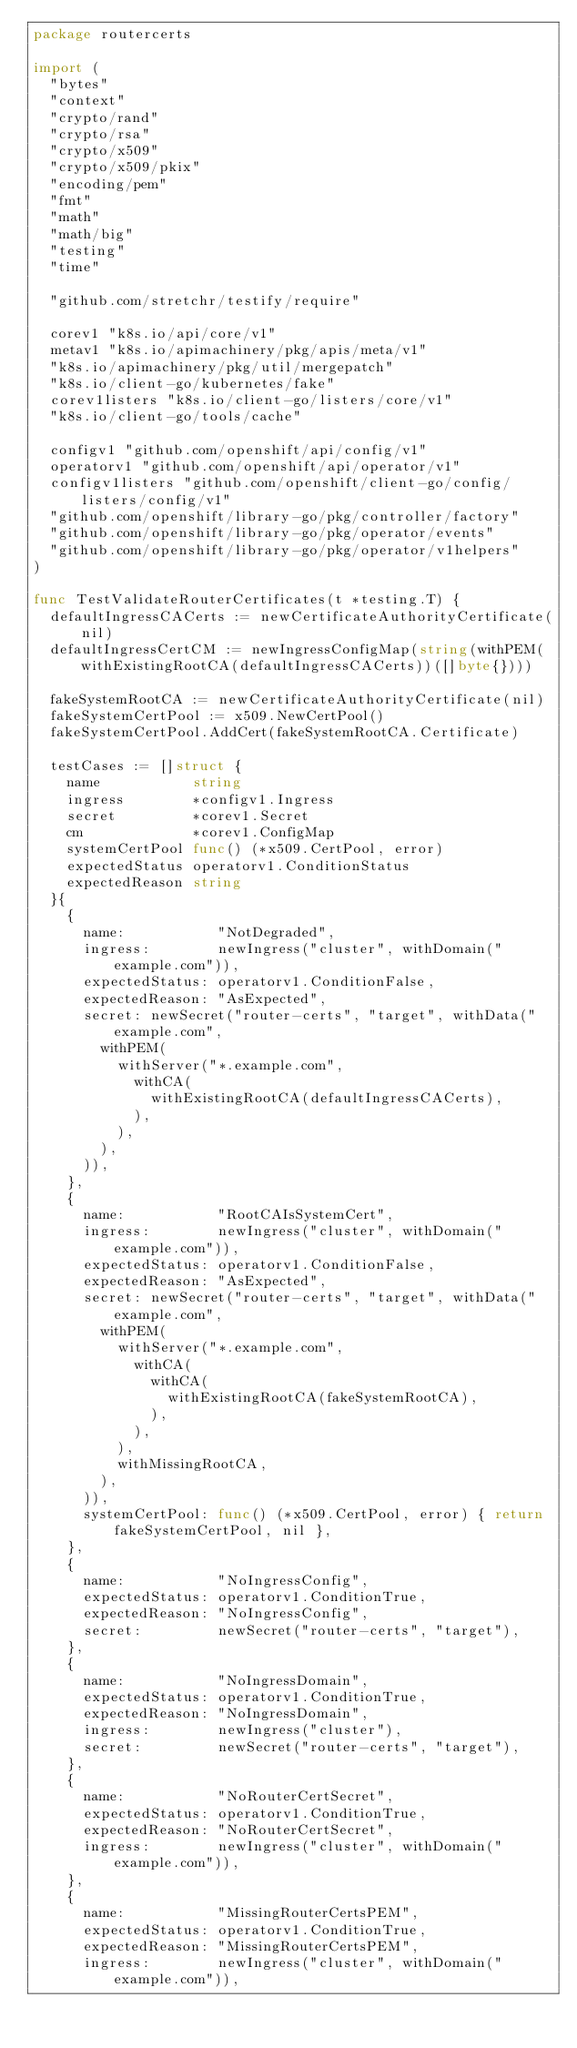<code> <loc_0><loc_0><loc_500><loc_500><_Go_>package routercerts

import (
	"bytes"
	"context"
	"crypto/rand"
	"crypto/rsa"
	"crypto/x509"
	"crypto/x509/pkix"
	"encoding/pem"
	"fmt"
	"math"
	"math/big"
	"testing"
	"time"

	"github.com/stretchr/testify/require"

	corev1 "k8s.io/api/core/v1"
	metav1 "k8s.io/apimachinery/pkg/apis/meta/v1"
	"k8s.io/apimachinery/pkg/util/mergepatch"
	"k8s.io/client-go/kubernetes/fake"
	corev1listers "k8s.io/client-go/listers/core/v1"
	"k8s.io/client-go/tools/cache"

	configv1 "github.com/openshift/api/config/v1"
	operatorv1 "github.com/openshift/api/operator/v1"
	configv1listers "github.com/openshift/client-go/config/listers/config/v1"
	"github.com/openshift/library-go/pkg/controller/factory"
	"github.com/openshift/library-go/pkg/operator/events"
	"github.com/openshift/library-go/pkg/operator/v1helpers"
)

func TestValidateRouterCertificates(t *testing.T) {
	defaultIngressCACerts := newCertificateAuthorityCertificate(nil)
	defaultIngressCertCM := newIngressConfigMap(string(withPEM(withExistingRootCA(defaultIngressCACerts))([]byte{})))

	fakeSystemRootCA := newCertificateAuthorityCertificate(nil)
	fakeSystemCertPool := x509.NewCertPool()
	fakeSystemCertPool.AddCert(fakeSystemRootCA.Certificate)

	testCases := []struct {
		name           string
		ingress        *configv1.Ingress
		secret         *corev1.Secret
		cm             *corev1.ConfigMap
		systemCertPool func() (*x509.CertPool, error)
		expectedStatus operatorv1.ConditionStatus
		expectedReason string
	}{
		{
			name:           "NotDegraded",
			ingress:        newIngress("cluster", withDomain("example.com")),
			expectedStatus: operatorv1.ConditionFalse,
			expectedReason: "AsExpected",
			secret: newSecret("router-certs", "target", withData("example.com",
				withPEM(
					withServer("*.example.com",
						withCA(
							withExistingRootCA(defaultIngressCACerts),
						),
					),
				),
			)),
		},
		{
			name:           "RootCAIsSystemCert",
			ingress:        newIngress("cluster", withDomain("example.com")),
			expectedStatus: operatorv1.ConditionFalse,
			expectedReason: "AsExpected",
			secret: newSecret("router-certs", "target", withData("example.com",
				withPEM(
					withServer("*.example.com",
						withCA(
							withCA(
								withExistingRootCA(fakeSystemRootCA),
							),
						),
					),
					withMissingRootCA,
				),
			)),
			systemCertPool: func() (*x509.CertPool, error) { return fakeSystemCertPool, nil },
		},
		{
			name:           "NoIngressConfig",
			expectedStatus: operatorv1.ConditionTrue,
			expectedReason: "NoIngressConfig",
			secret:         newSecret("router-certs", "target"),
		},
		{
			name:           "NoIngressDomain",
			expectedStatus: operatorv1.ConditionTrue,
			expectedReason: "NoIngressDomain",
			ingress:        newIngress("cluster"),
			secret:         newSecret("router-certs", "target"),
		},
		{
			name:           "NoRouterCertSecret",
			expectedStatus: operatorv1.ConditionTrue,
			expectedReason: "NoRouterCertSecret",
			ingress:        newIngress("cluster", withDomain("example.com")),
		},
		{
			name:           "MissingRouterCertsPEM",
			expectedStatus: operatorv1.ConditionTrue,
			expectedReason: "MissingRouterCertsPEM",
			ingress:        newIngress("cluster", withDomain("example.com")),</code> 